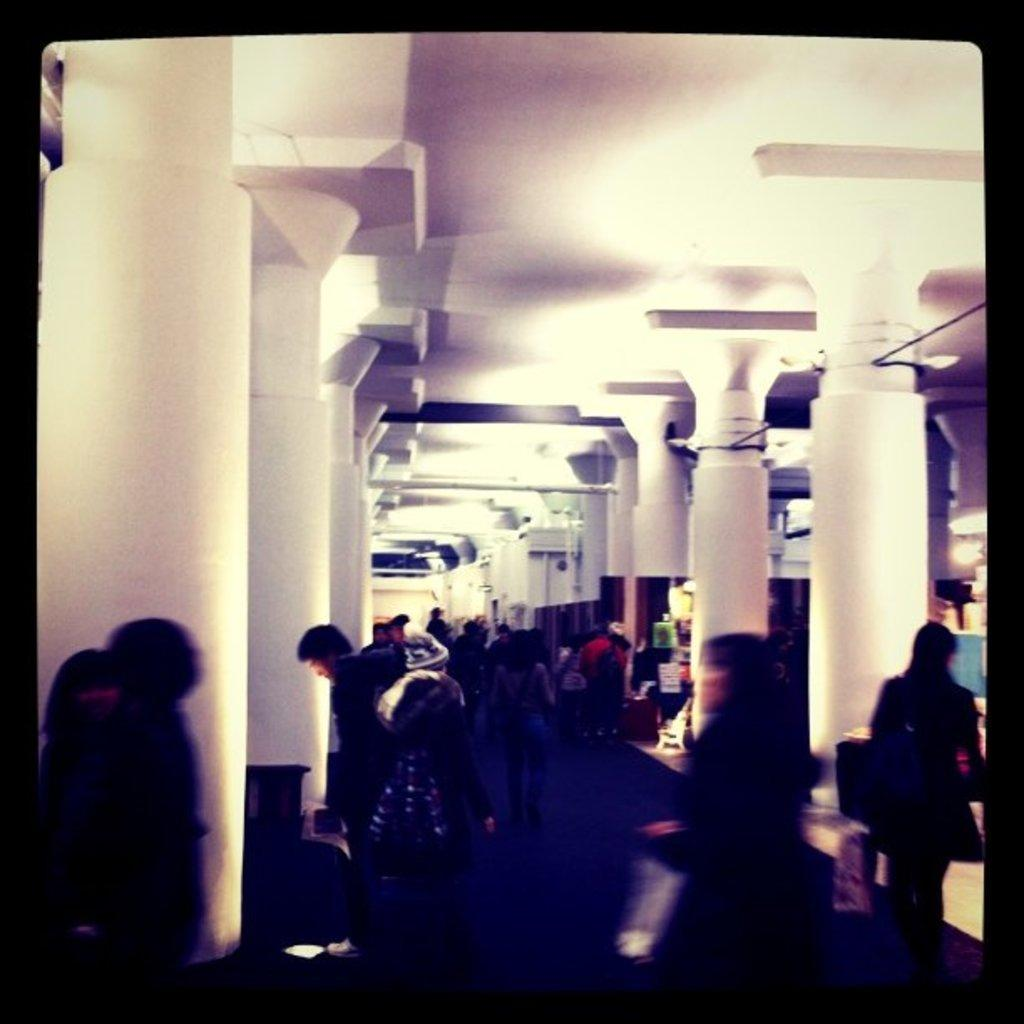What are the people in the image doing? The people in the image are walking inside a building. What architectural features can be seen in the building? There are pillars in the building. How many bricks can be seen in the image? There is no mention of bricks in the provided facts, so it is impossible to determine how many bricks are present in the image. Are there any giants visible in the image? There is no mention of giants in the provided facts, so it is impossible to determine if any giants are present in the image. 